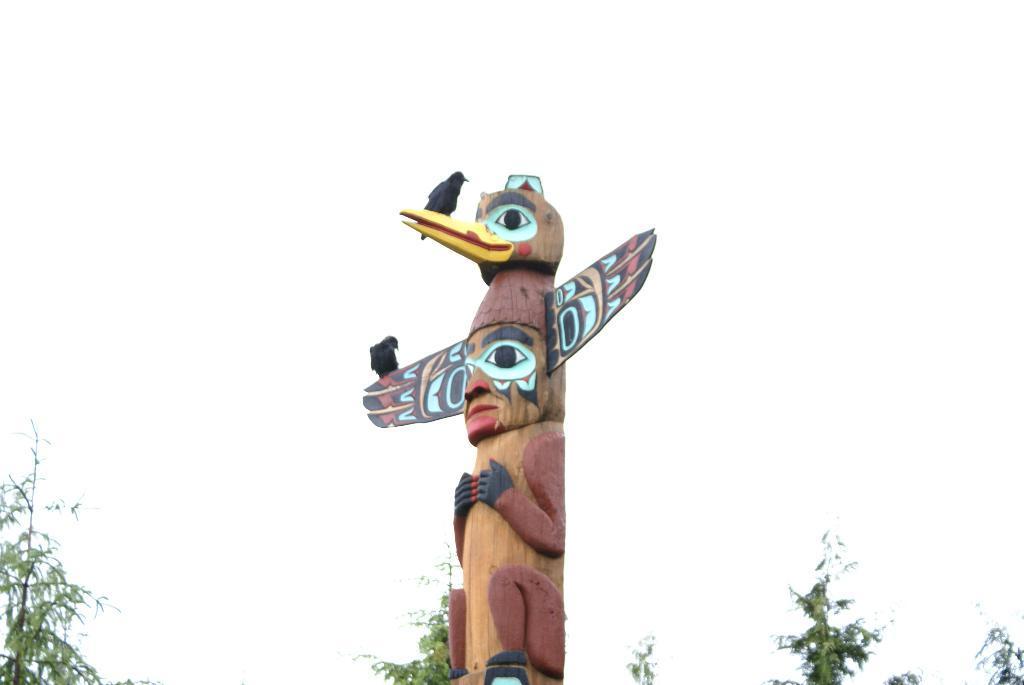How would you summarize this image in a sentence or two? In this image we can see a statue, two birds on the statue, few trees and the sky in the background. 